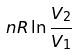<formula> <loc_0><loc_0><loc_500><loc_500>n R \ln \frac { V _ { 2 } } { V _ { 1 } }</formula> 